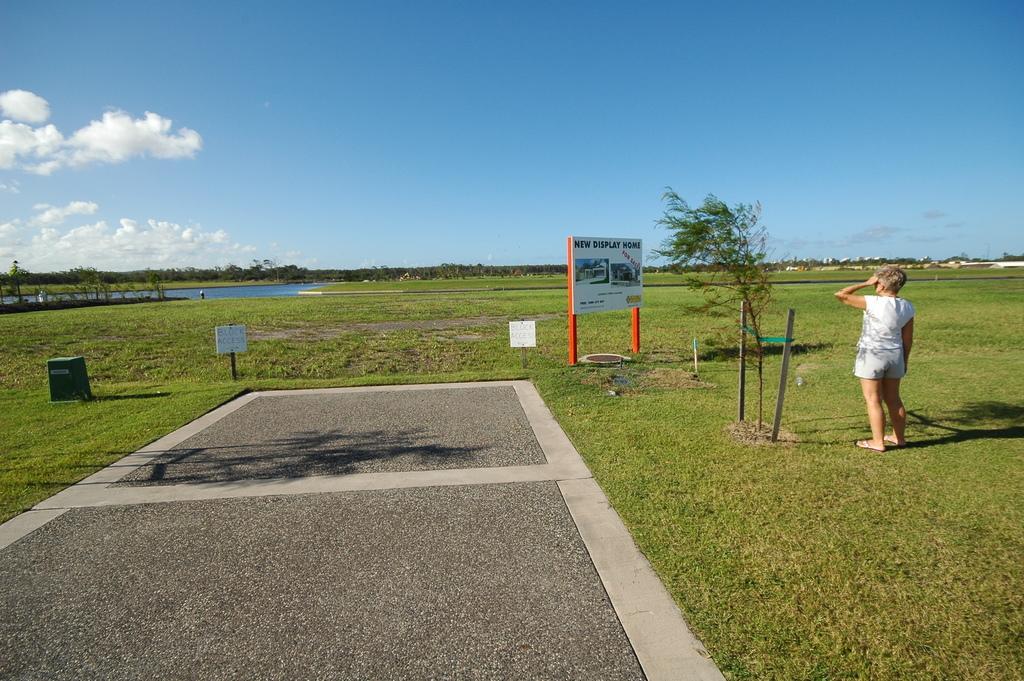In one or two sentences, can you explain what this image depicts? In this image there is a ground , on which there is a board, on which there is a text, poles, plants, water, person, at the top there is the sky. 